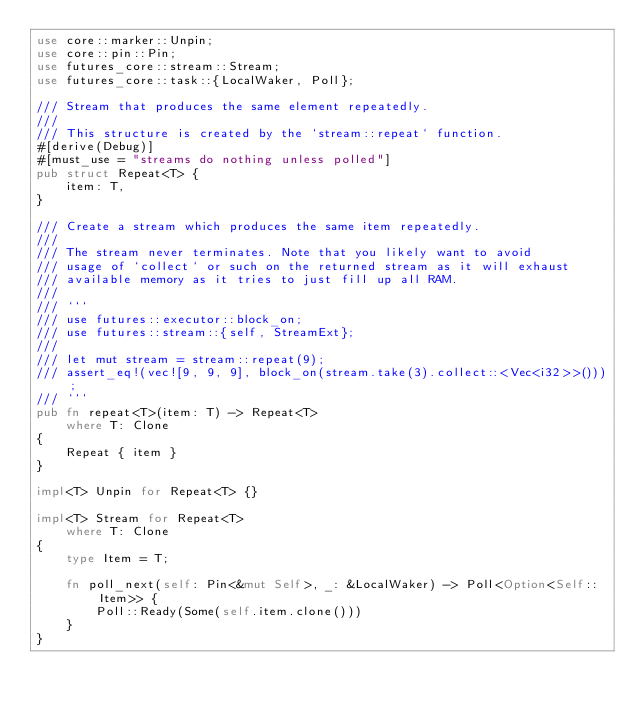Convert code to text. <code><loc_0><loc_0><loc_500><loc_500><_Rust_>use core::marker::Unpin;
use core::pin::Pin;
use futures_core::stream::Stream;
use futures_core::task::{LocalWaker, Poll};

/// Stream that produces the same element repeatedly.
///
/// This structure is created by the `stream::repeat` function.
#[derive(Debug)]
#[must_use = "streams do nothing unless polled"]
pub struct Repeat<T> {
    item: T,
}

/// Create a stream which produces the same item repeatedly.
///
/// The stream never terminates. Note that you likely want to avoid
/// usage of `collect` or such on the returned stream as it will exhaust
/// available memory as it tries to just fill up all RAM.
///
/// ```
/// use futures::executor::block_on;
/// use futures::stream::{self, StreamExt};
///
/// let mut stream = stream::repeat(9);
/// assert_eq!(vec![9, 9, 9], block_on(stream.take(3).collect::<Vec<i32>>()));
/// ```
pub fn repeat<T>(item: T) -> Repeat<T>
    where T: Clone
{
    Repeat { item }
}

impl<T> Unpin for Repeat<T> {}

impl<T> Stream for Repeat<T>
    where T: Clone
{
    type Item = T;

    fn poll_next(self: Pin<&mut Self>, _: &LocalWaker) -> Poll<Option<Self::Item>> {
        Poll::Ready(Some(self.item.clone()))
    }
}
</code> 